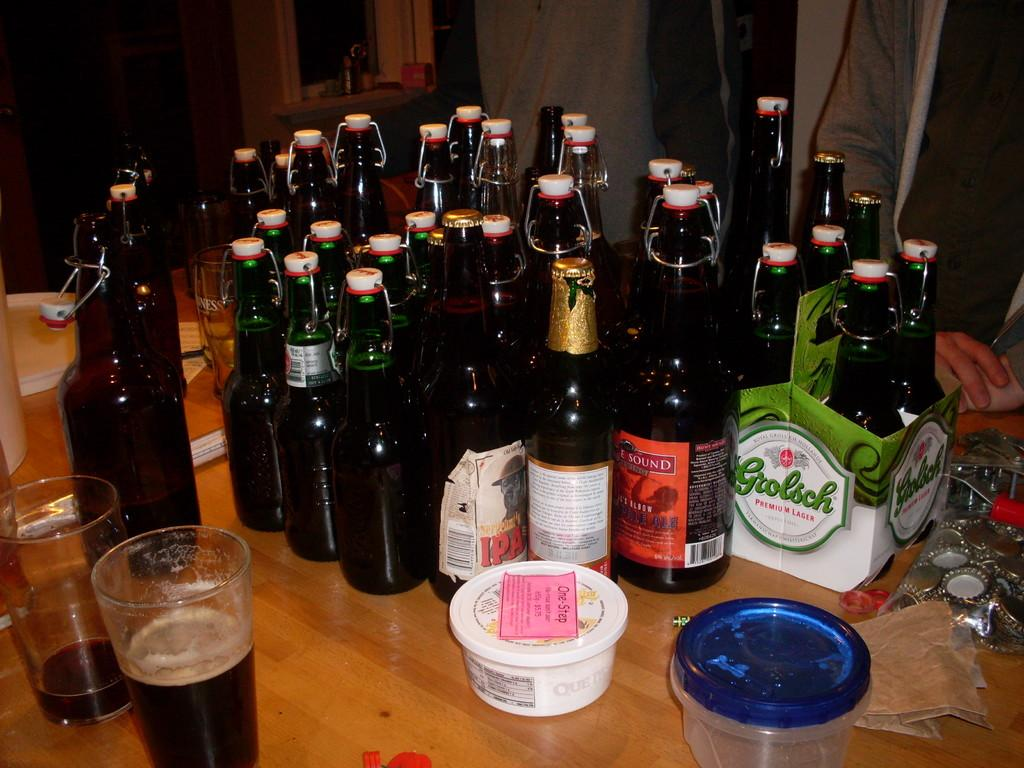<image>
Give a short and clear explanation of the subsequent image. A table that has a lot of Grosch beer and various other IPA beer. 